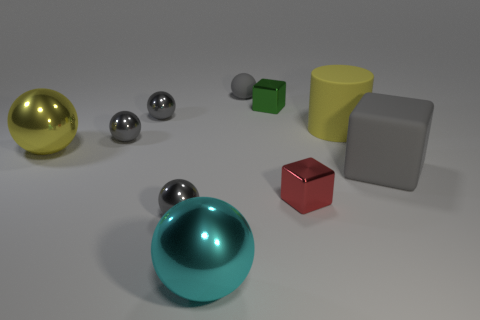How many gray balls must be subtracted to get 2 gray balls? 2 Subtract all large metal balls. How many balls are left? 4 Subtract all red blocks. How many blocks are left? 2 Subtract 6 spheres. How many spheres are left? 0 Subtract all gray cylinders. How many gray cubes are left? 1 Subtract all cylinders. How many objects are left? 9 Subtract all cyan cubes. Subtract all blue cylinders. How many cubes are left? 3 Subtract all shiny things. Subtract all rubber balls. How many objects are left? 2 Add 5 cyan metallic spheres. How many cyan metallic spheres are left? 6 Add 10 large red cylinders. How many large red cylinders exist? 10 